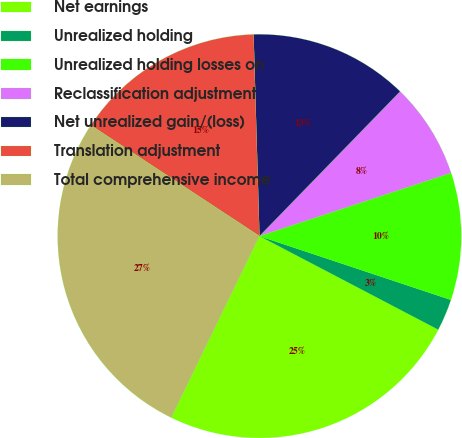Convert chart to OTSL. <chart><loc_0><loc_0><loc_500><loc_500><pie_chart><fcel>Net earnings<fcel>Unrealized holding<fcel>Unrealized holding losses on<fcel>Reclassification adjustment<fcel>Net unrealized gain/(loss)<fcel>Translation adjustment<fcel>Total comprehensive income<nl><fcel>24.52%<fcel>2.56%<fcel>10.19%<fcel>7.65%<fcel>12.74%<fcel>15.28%<fcel>27.06%<nl></chart> 